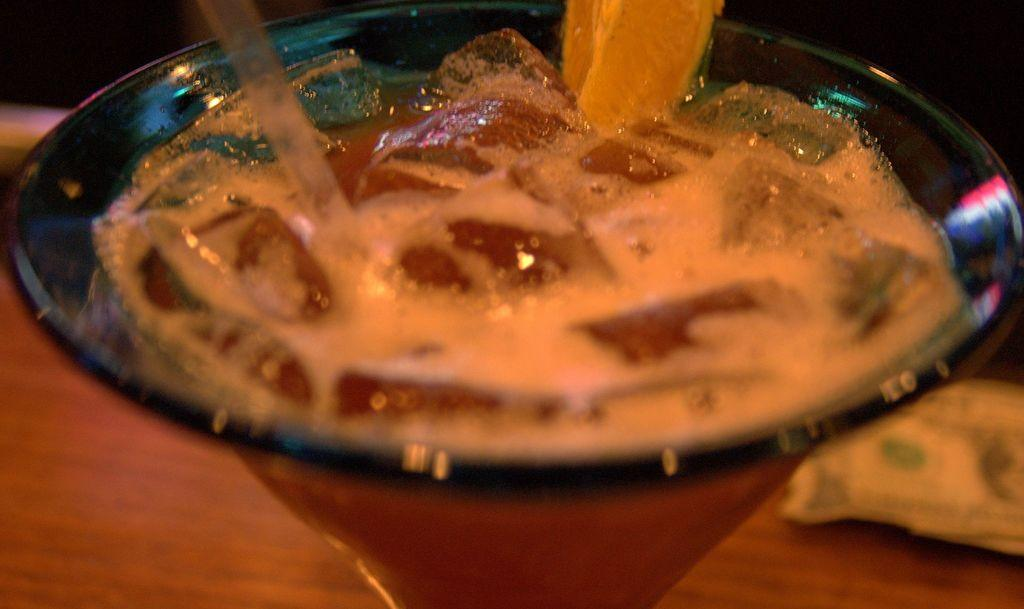What is in the bowl that is visible in the image? There is food placed in a bowl in the image, and it contains a fruit. Can you describe the type of food in the bowl? The food in the bowl is not specified, but it contains a fruit. What else can be seen in the image besides the bowl of food? There is a currency note visible in the background of the image. What type of noise can be heard coming from the fruit in the image? There is no noise coming from the fruit in the image, as it is a still image and not a video or audio recording. 